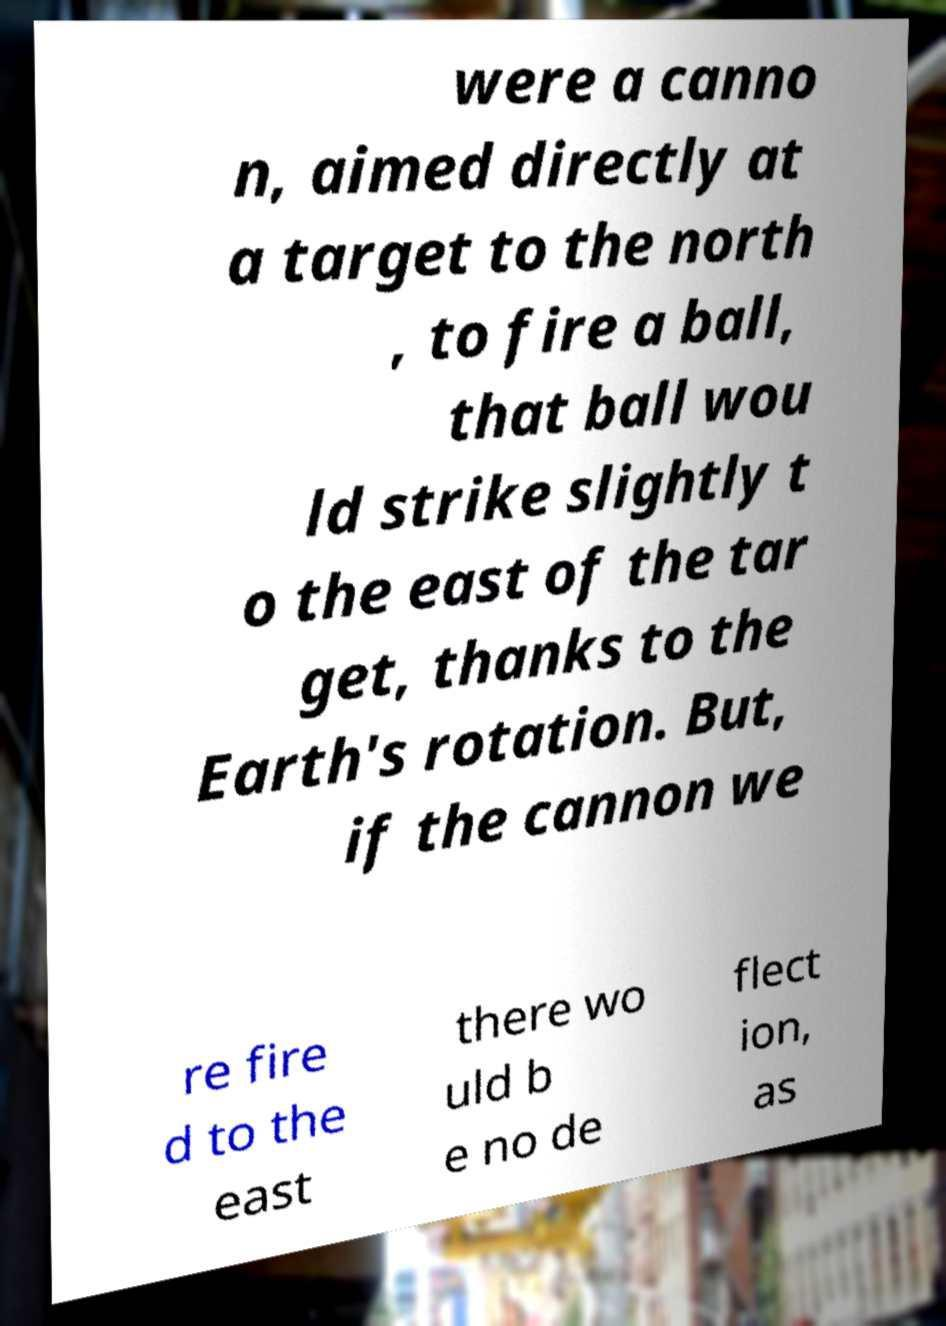For documentation purposes, I need the text within this image transcribed. Could you provide that? were a canno n, aimed directly at a target to the north , to fire a ball, that ball wou ld strike slightly t o the east of the tar get, thanks to the Earth's rotation. But, if the cannon we re fire d to the east there wo uld b e no de flect ion, as 